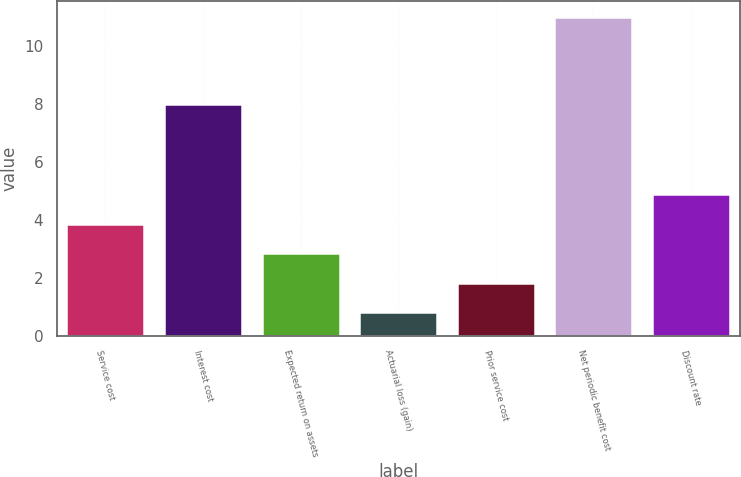Convert chart to OTSL. <chart><loc_0><loc_0><loc_500><loc_500><bar_chart><fcel>Service cost<fcel>Interest cost<fcel>Expected return on assets<fcel>Actuarial loss (gain)<fcel>Prior service cost<fcel>Net periodic benefit cost<fcel>Discount rate<nl><fcel>3.86<fcel>8<fcel>2.84<fcel>0.8<fcel>1.82<fcel>11<fcel>4.88<nl></chart> 